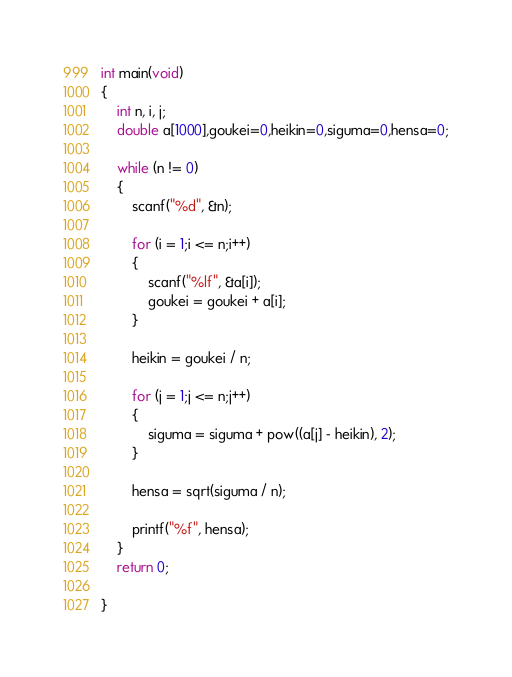Convert code to text. <code><loc_0><loc_0><loc_500><loc_500><_C_>int main(void)
{
    int n, i, j;
    double a[1000],goukei=0,heikin=0,siguma=0,hensa=0;

    while (n != 0)
    {
        scanf("%d", &n);

        for (i = 1;i <= n;i++)
        {
            scanf("%lf", &a[i]);
            goukei = goukei + a[i];
        }

        heikin = goukei / n;

        for (j = 1;j <= n;j++)
        {
            siguma = siguma + pow((a[j] - heikin), 2);
        }

        hensa = sqrt(siguma / n);

        printf("%f", hensa);
    }
    return 0;

}
</code> 